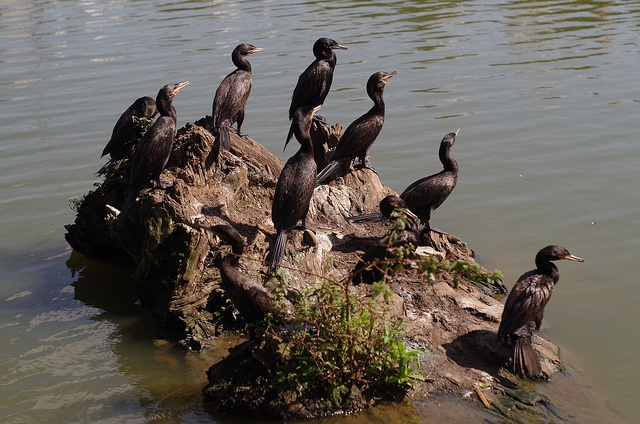Describe the objects in this image and their specific colors. I can see bird in darkgray, black, gray, and maroon tones, bird in darkgray, black, gray, and maroon tones, bird in darkgray, black, and gray tones, bird in darkgray, black, and gray tones, and bird in darkgray, black, gray, and maroon tones in this image. 